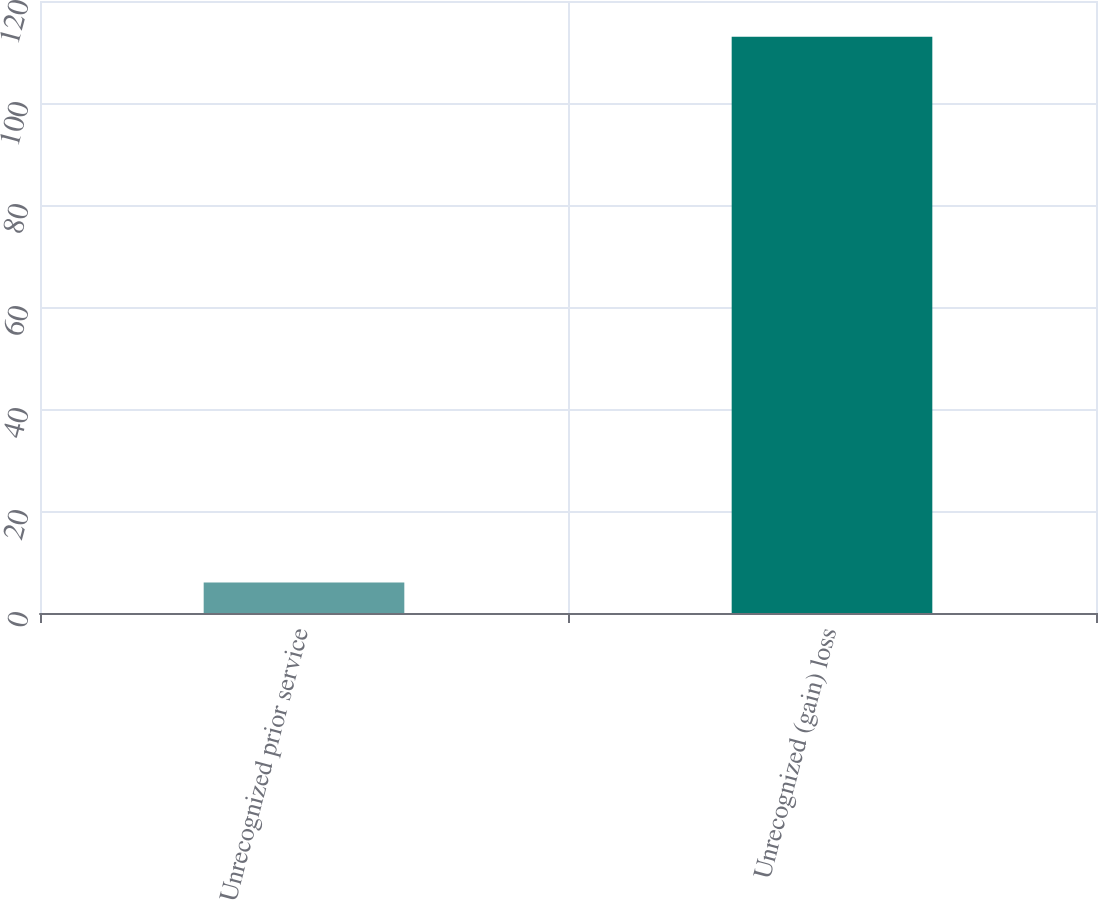<chart> <loc_0><loc_0><loc_500><loc_500><bar_chart><fcel>Unrecognized prior service<fcel>Unrecognized (gain) loss<nl><fcel>6<fcel>113<nl></chart> 